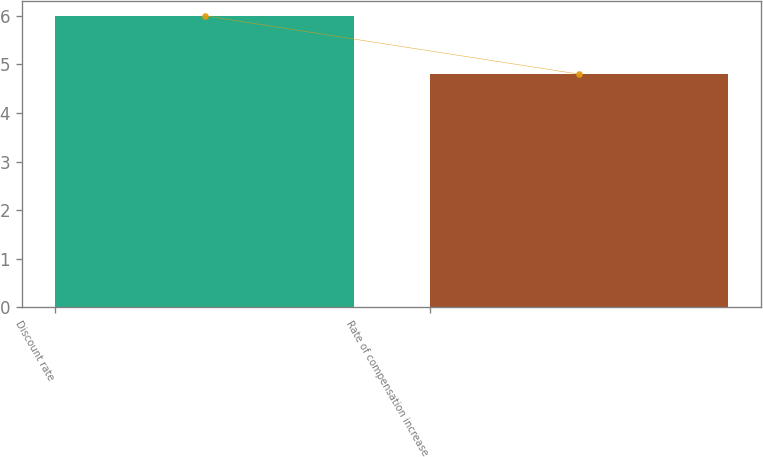Convert chart. <chart><loc_0><loc_0><loc_500><loc_500><bar_chart><fcel>Discount rate<fcel>Rate of compensation increase<nl><fcel>6<fcel>4.8<nl></chart> 